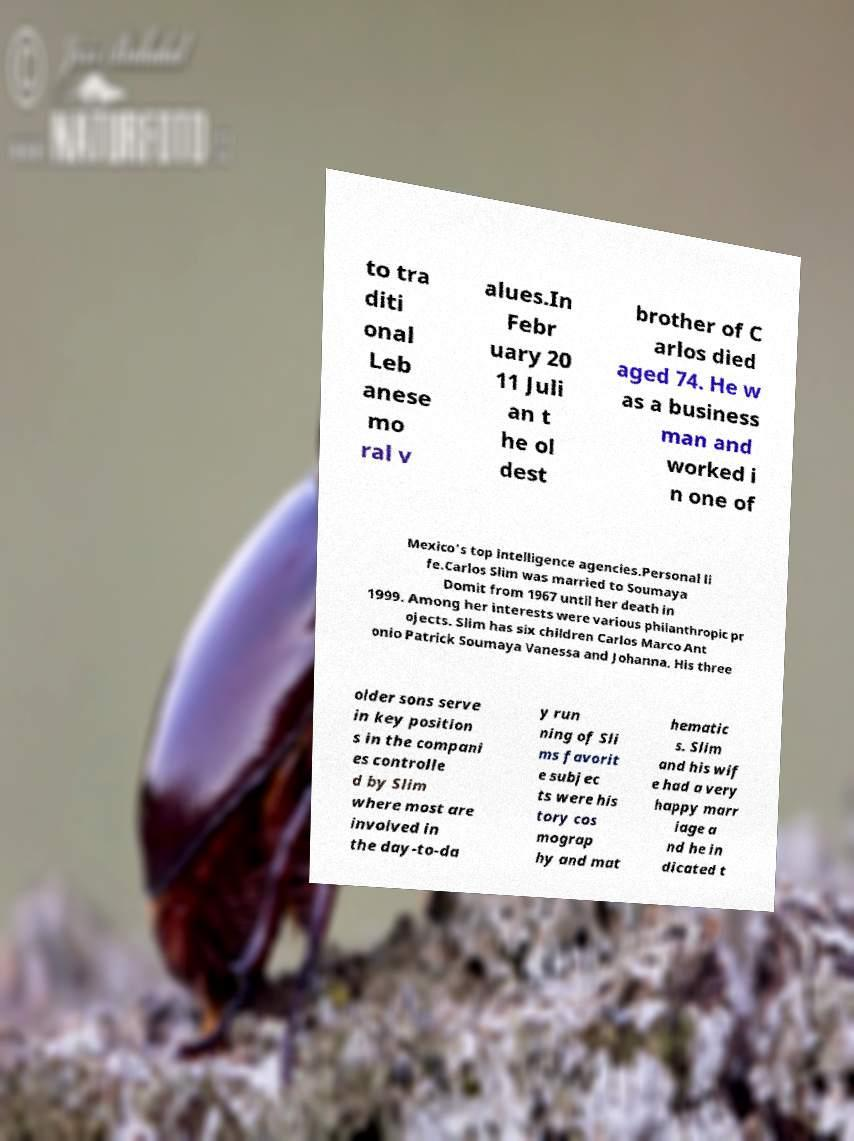There's text embedded in this image that I need extracted. Can you transcribe it verbatim? to tra diti onal Leb anese mo ral v alues.In Febr uary 20 11 Juli an t he ol dest brother of C arlos died aged 74. He w as a business man and worked i n one of Mexico's top intelligence agencies.Personal li fe.Carlos Slim was married to Soumaya Domit from 1967 until her death in 1999. Among her interests were various philanthropic pr ojects. Slim has six children Carlos Marco Ant onio Patrick Soumaya Vanessa and Johanna. His three older sons serve in key position s in the compani es controlle d by Slim where most are involved in the day-to-da y run ning of Sli ms favorit e subjec ts were his tory cos mograp hy and mat hematic s. Slim and his wif e had a very happy marr iage a nd he in dicated t 